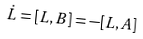Convert formula to latex. <formula><loc_0><loc_0><loc_500><loc_500>\dot { L } = [ L , B ] = - [ L , A ]</formula> 